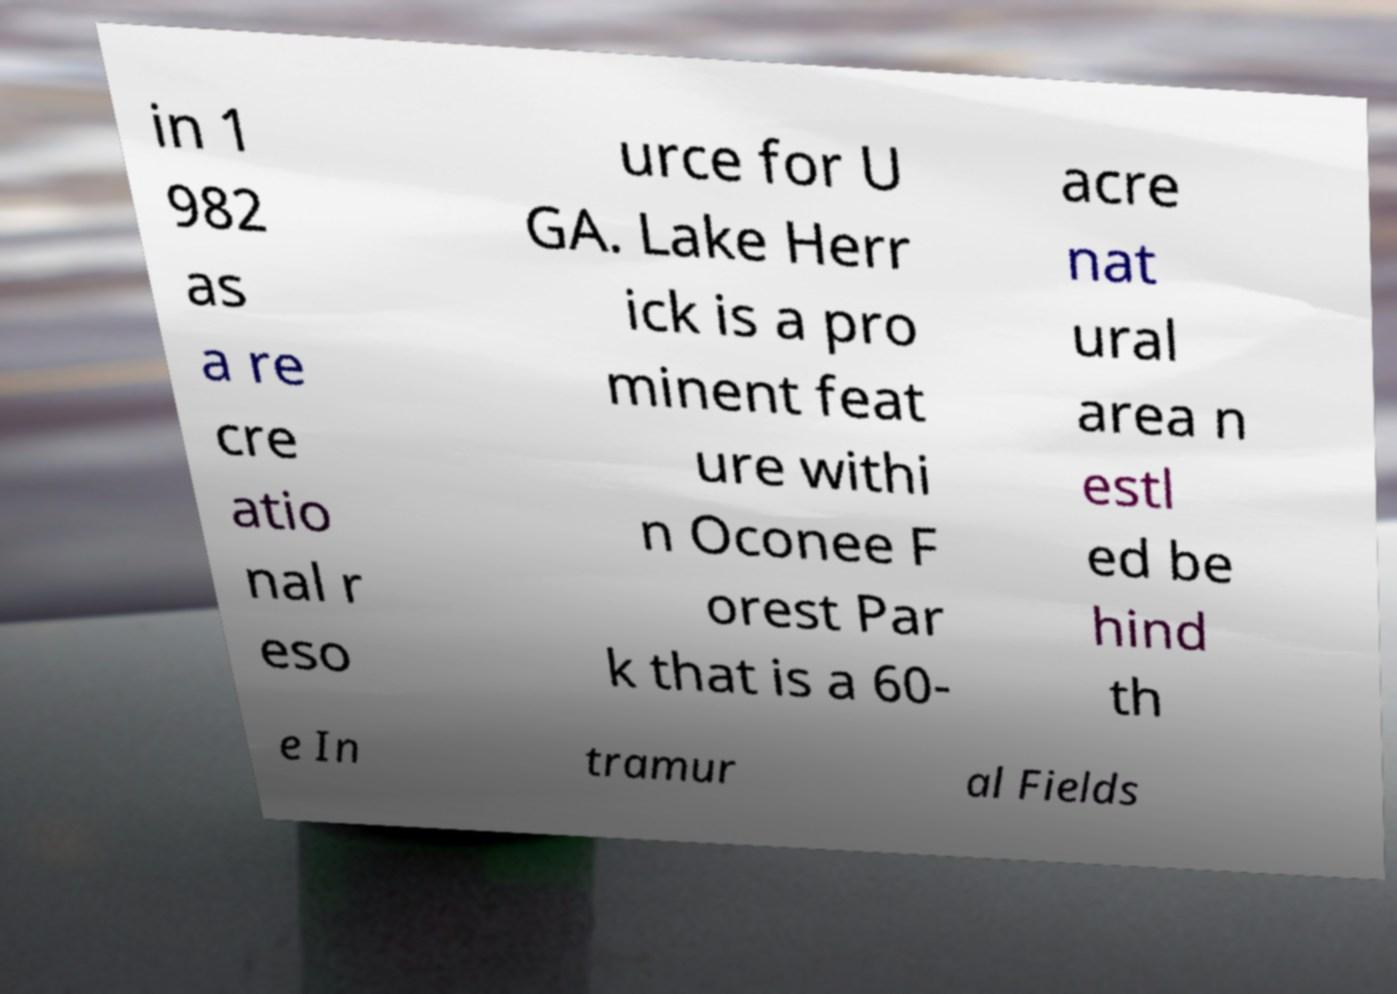Can you read and provide the text displayed in the image?This photo seems to have some interesting text. Can you extract and type it out for me? in 1 982 as a re cre atio nal r eso urce for U GA. Lake Herr ick is a pro minent feat ure withi n Oconee F orest Par k that is a 60- acre nat ural area n estl ed be hind th e In tramur al Fields 